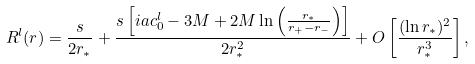<formula> <loc_0><loc_0><loc_500><loc_500>R ^ { l } ( r ) = \frac { s } { 2 r _ { * } } + \frac { s \left [ i a c _ { 0 } ^ { l } - 3 M + 2 M \ln \left ( \frac { r _ { * } } { r _ { + } - r _ { - } } \right ) \right ] } { 2 r _ { * } ^ { 2 } } + O \left [ \frac { ( \ln r _ { * } ) ^ { 2 } } { r _ { * } ^ { 3 } } \right ] ,</formula> 